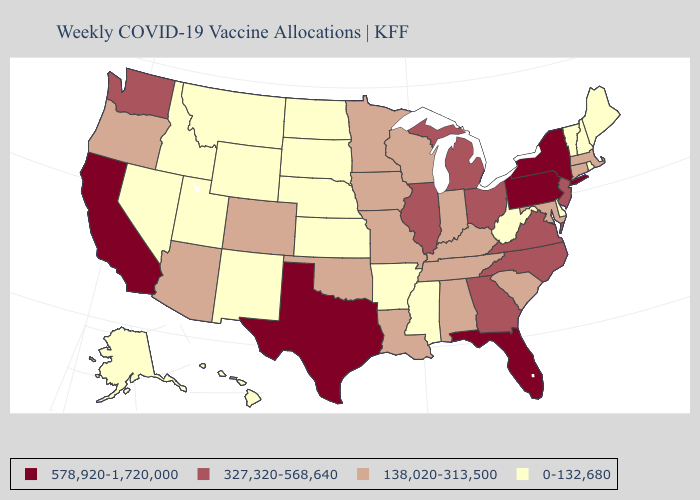Does Ohio have the same value as Michigan?
Give a very brief answer. Yes. What is the lowest value in the MidWest?
Write a very short answer. 0-132,680. Does the map have missing data?
Answer briefly. No. Among the states that border Massachusetts , which have the highest value?
Concise answer only. New York. What is the value of Nebraska?
Write a very short answer. 0-132,680. What is the value of Ohio?
Concise answer only. 327,320-568,640. Name the states that have a value in the range 138,020-313,500?
Write a very short answer. Alabama, Arizona, Colorado, Connecticut, Indiana, Iowa, Kentucky, Louisiana, Maryland, Massachusetts, Minnesota, Missouri, Oklahoma, Oregon, South Carolina, Tennessee, Wisconsin. What is the value of Utah?
Quick response, please. 0-132,680. What is the highest value in the South ?
Short answer required. 578,920-1,720,000. Name the states that have a value in the range 0-132,680?
Give a very brief answer. Alaska, Arkansas, Delaware, Hawaii, Idaho, Kansas, Maine, Mississippi, Montana, Nebraska, Nevada, New Hampshire, New Mexico, North Dakota, Rhode Island, South Dakota, Utah, Vermont, West Virginia, Wyoming. What is the highest value in states that border Ohio?
Be succinct. 578,920-1,720,000. What is the value of Maryland?
Answer briefly. 138,020-313,500. Which states have the lowest value in the USA?
Quick response, please. Alaska, Arkansas, Delaware, Hawaii, Idaho, Kansas, Maine, Mississippi, Montana, Nebraska, Nevada, New Hampshire, New Mexico, North Dakota, Rhode Island, South Dakota, Utah, Vermont, West Virginia, Wyoming. What is the value of North Carolina?
Keep it brief. 327,320-568,640. What is the value of Hawaii?
Short answer required. 0-132,680. 